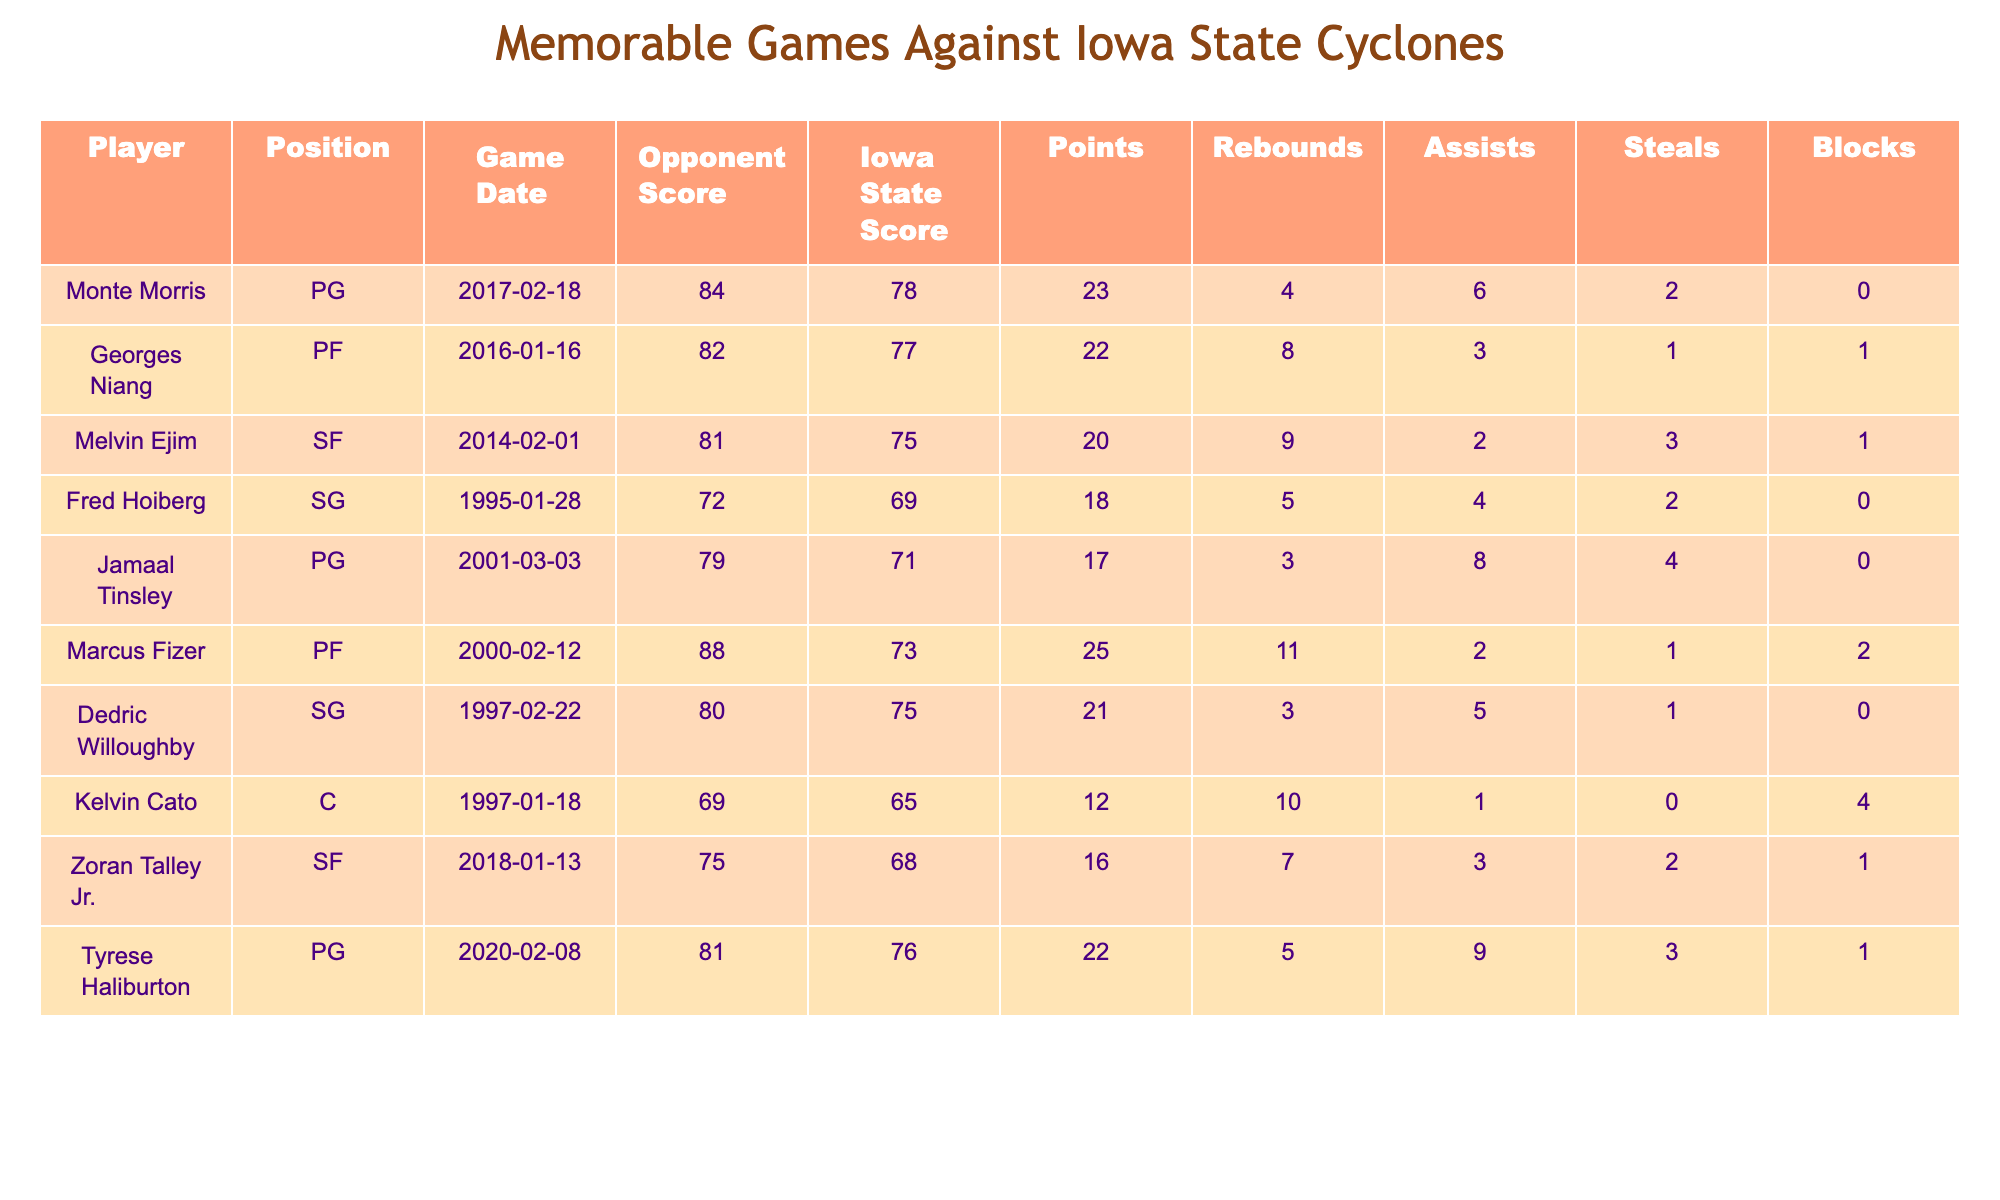What player scored the highest number of points in a game against Iowa State? By examining the "Points" column, I can see that Marcus Fizer scored 25 points against Iowa State on February 12, 2000, which is the highest compared to other players in the table.
Answer: 25 Which player had the most rebounds in a single game against Iowa State? Looking at the "Rebounds" column, Marcus Fizer recorded the highest number of rebounds with 11 during the game on February 12, 2000, making him the player with the most rebounds in this table.
Answer: 11 How many assists did Tyrese Haliburton have in his game against Iowa State? In the "Assists" column for Tyrese Haliburton's game on February 8, 2020, it shows that he had 9 assists, which answers the question directly.
Answer: 9 What was the average number of points scored by the players in the table? To find the average points, I add all the points: 23 + 22 + 20 + 18 + 17 + 25 + 21 + 12 + 16 + 22 = 204. There are 10 players, so I divide the total points by 10: 204/10 = 20.4.
Answer: 20.4 Did any player record a double-digit score in both points and rebounds in their game against Iowa State? Upon reviewing the table, I see that Marcus Fizer scored 25 points and had 11 rebounds, both of which are double digits. Therefore, the answer is yes.
Answer: Yes Which player had the least number of points scored, and what was that score? Scanning the "Points" column, I find that Kelvin Cato had the least number of points, scoring 12 against Iowa State on January 18, 1997.
Answer: 12 Determine the total number of assists made by all players in the table. I sum the assists: 6 + 3 + 2 + 4 + 8 + 2 + 5 + 1 + 3 + 9 = 43. Therefore, the total number of assists is 43.
Answer: 43 Who played the position of shooting guard for Iowa State in one of these games? The table lists Fred Hoiberg (SG) and Dedric Willoughby (SG) as shooting guards who played in games against Iowa State on January 28, 1995, and February 22, 1997, respectively.
Answer: Fred Hoiberg and Dedric Willoughby Was there a game where a player had more steals than assists? By analyzing the "Steals" and "Assists" columns, I see Fred Hoiberg had 2 steals and 4 assists, Jamaal Tinsley had 4 steals and 8 assists, and others as well; however, Zoran Talley Jr. had 2 steals and 3 assists, meaningthere are games where players had fewer assists than steals.
Answer: Yes What is the combined score of the opponents against Iowa State in these games? By summing the "Opponent Score" column, I add: 84 + 82 + 81 + 72 + 79 + 88 + 80 + 69 + 75 + 81 = 810. The total score of the opponents is 810.
Answer: 810 